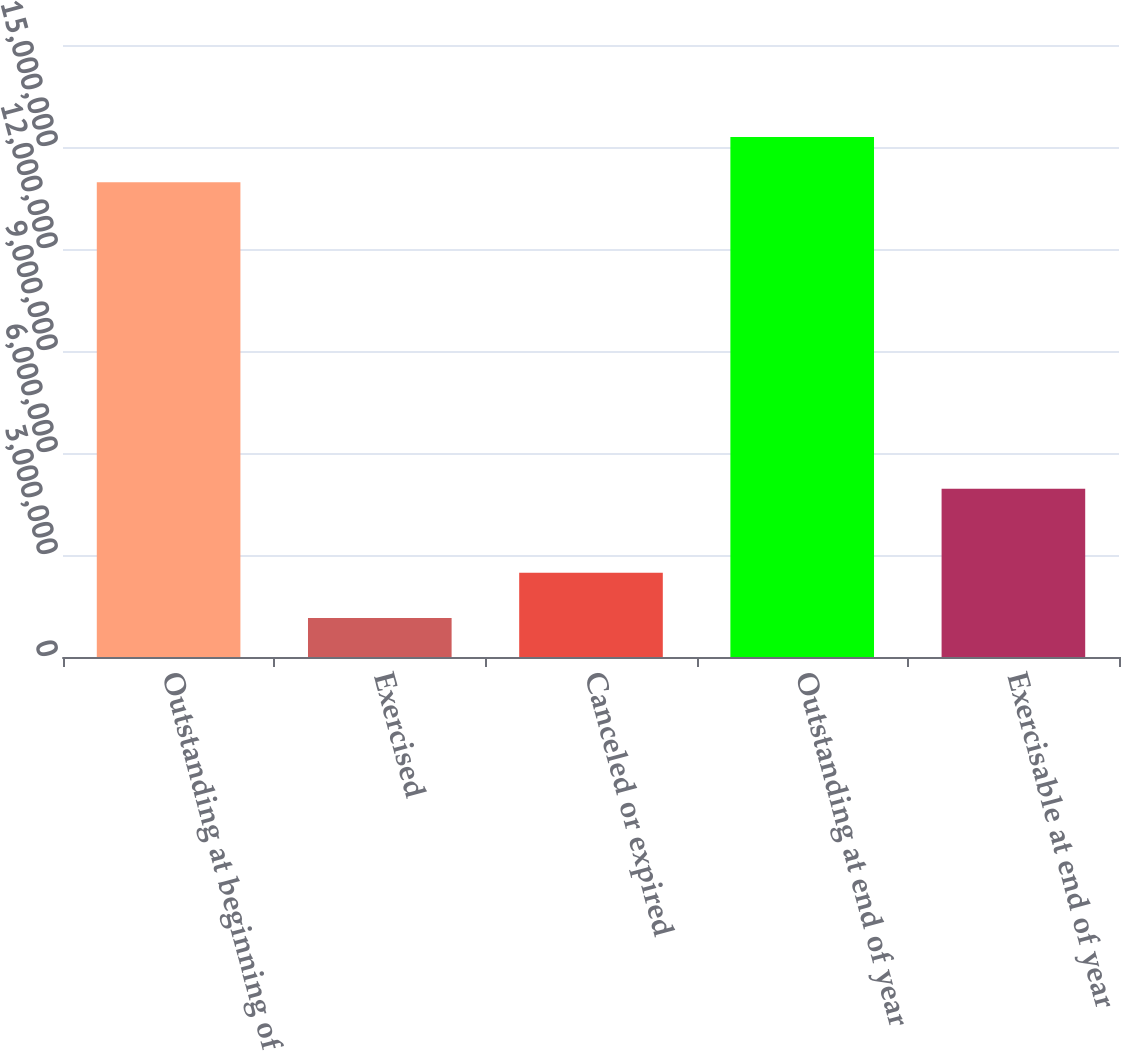Convert chart. <chart><loc_0><loc_0><loc_500><loc_500><bar_chart><fcel>Outstanding at beginning of<fcel>Exercised<fcel>Canceled or expired<fcel>Outstanding at end of year<fcel>Exercisable at end of year<nl><fcel>1.39656e+07<fcel>1.14943e+06<fcel>2.47986e+06<fcel>1.52961e+07<fcel>4.94554e+06<nl></chart> 